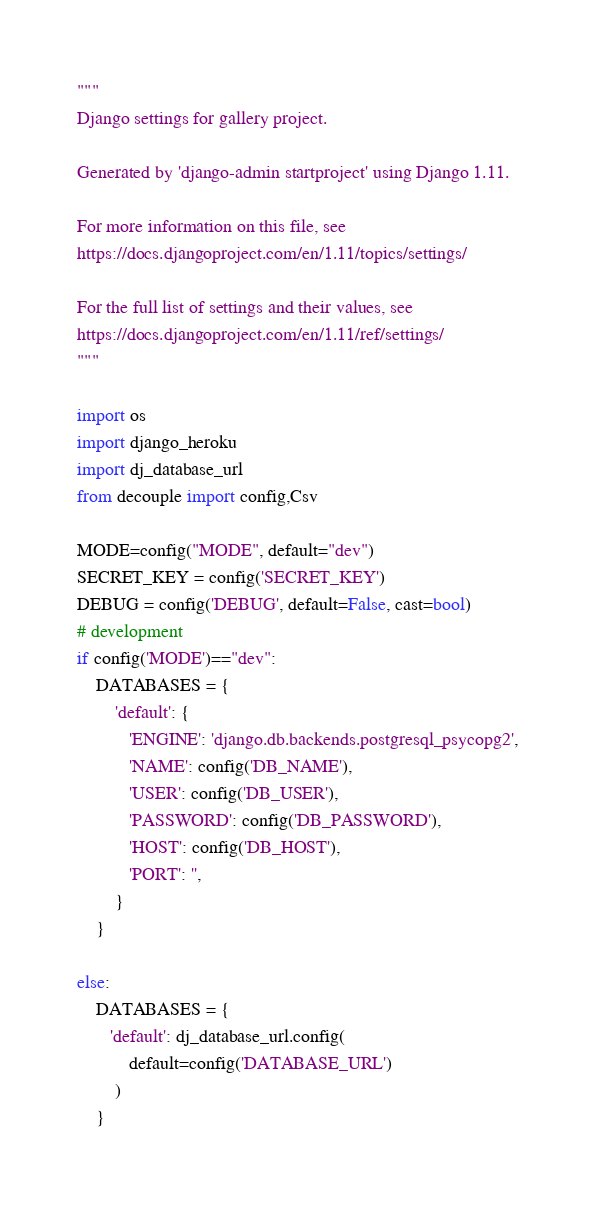Convert code to text. <code><loc_0><loc_0><loc_500><loc_500><_Python_>"""
Django settings for gallery project.

Generated by 'django-admin startproject' using Django 1.11.

For more information on this file, see
https://docs.djangoproject.com/en/1.11/topics/settings/

For the full list of settings and their values, see
https://docs.djangoproject.com/en/1.11/ref/settings/
"""

import os
import django_heroku
import dj_database_url
from decouple import config,Csv

MODE=config("MODE", default="dev")
SECRET_KEY = config('SECRET_KEY')
DEBUG = config('DEBUG', default=False, cast=bool)
# development
if config('MODE')=="dev":
    DATABASES = {
        'default': {
           'ENGINE': 'django.db.backends.postgresql_psycopg2',
           'NAME': config('DB_NAME'),
           'USER': config('DB_USER'),
           'PASSWORD': config('DB_PASSWORD'),
           'HOST': config('DB_HOST'),
           'PORT': '',
        }
    }

else:
    DATABASES = {
       'default': dj_database_url.config(
           default=config('DATABASE_URL')
        )
    }
</code> 